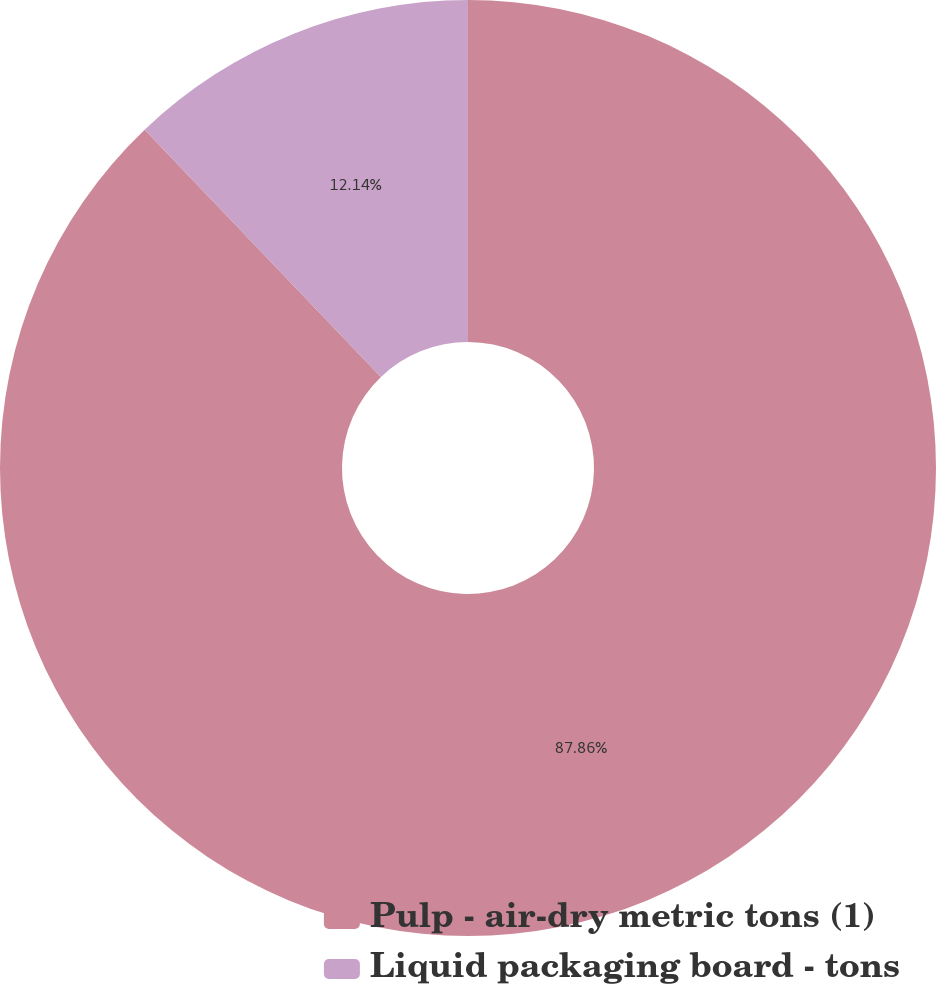<chart> <loc_0><loc_0><loc_500><loc_500><pie_chart><fcel>Pulp - air-dry metric tons (1)<fcel>Liquid packaging board - tons<nl><fcel>87.86%<fcel>12.14%<nl></chart> 